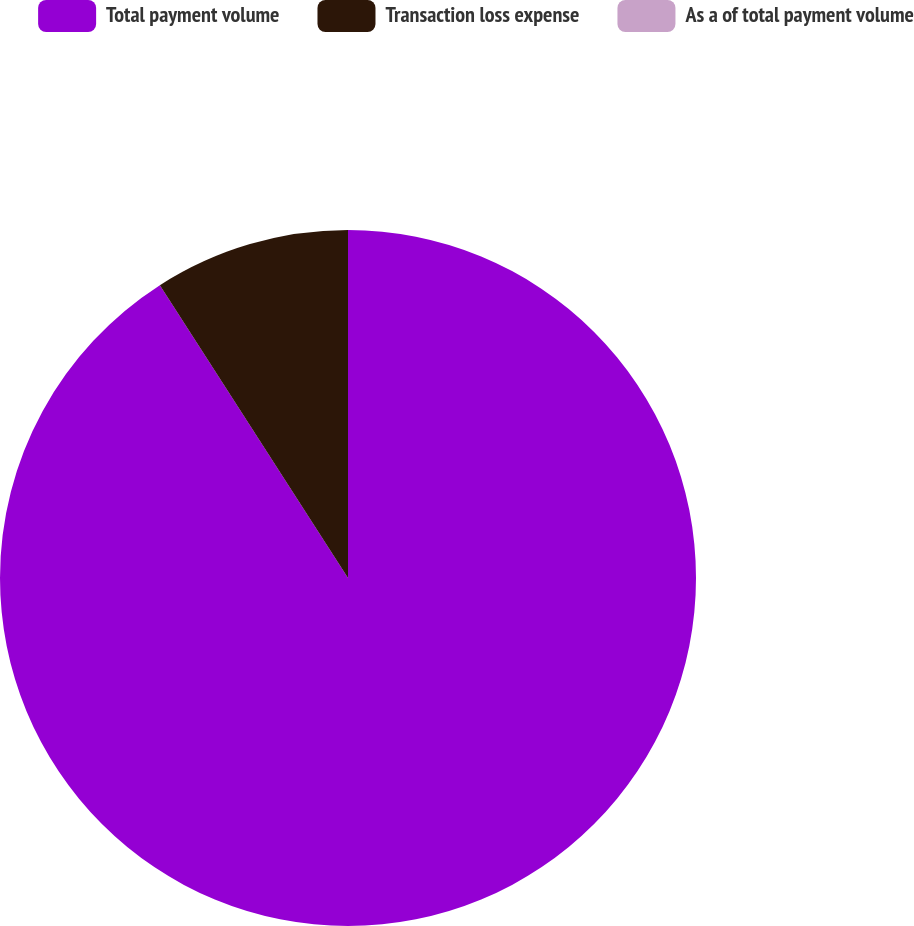Convert chart. <chart><loc_0><loc_0><loc_500><loc_500><pie_chart><fcel>Total payment volume<fcel>Transaction loss expense<fcel>As a of total payment volume<nl><fcel>90.91%<fcel>9.09%<fcel>0.0%<nl></chart> 